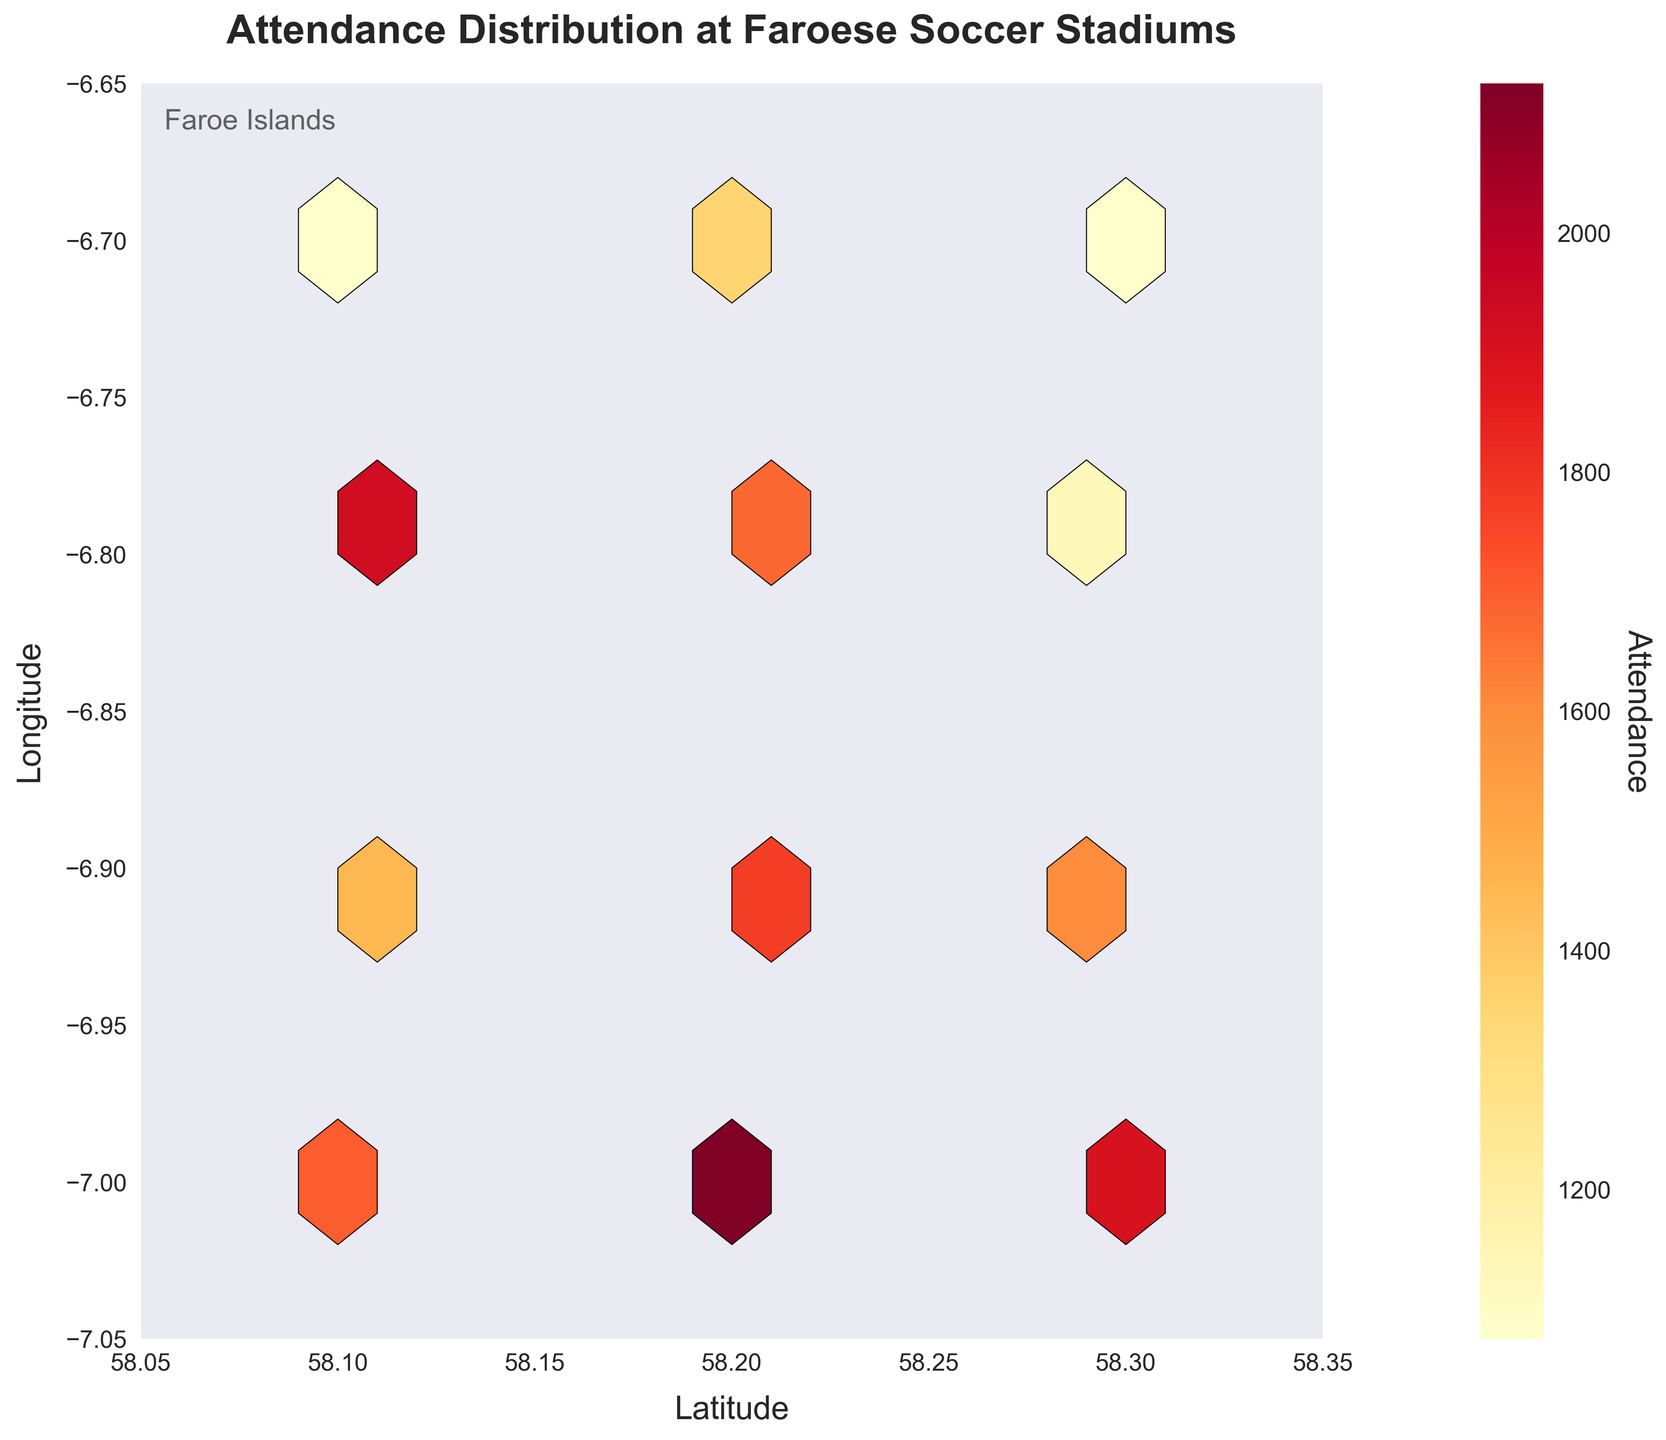What's the title of the plot? The title is usually prominently displayed at the top of the plot. Checking the provided plot, the title is "Attendance Distribution at Faroese Soccer Stadiums".
Answer: Attendance Distribution at Faroese Soccer Stadiums What do the colors represent in the hexbin plot? In a hexbin plot, colors are used to represent the magnitude or density of the underlying values within the hexagons. In this plot, the color bar indicates that the colors from yellow to red represent increasing attendance.
Answer: Attendance levels What are the x and y-axis labels? Axes labels are usually found next to the axes. From the plot, the x-axis is labeled "Latitude" and the y-axis is labeled "Longitude".
Answer: Latitude; Longitude Which latitude and longitude range does this plot cover? The axes limits can usually be inferred by looking at the ticks on the edges of the plot. The latitude ranges from 58.05 to 58.35 and the longitude ranges from -7.05 to -6.65.
Answer: Latitude: 58.05 to 58.35; Longitude: -7.05 to -6.65 What area seems to have the highest concentration of attendance? Areas of highest density are usually depicted in the darkest or most intense colors. The highest concentration in this plot is around (58.2, -6.8) as it is the darkest region.
Answer: Around (58.2, -6.8) Do more northern or southern stadiums appear to have higher attendances on average? By comparing the overall color intensity between the northern and southern regions, you can determine which has higher attendances. More northern stadiums (higher latitudes) appear to have a deeper color, indicating higher attendances.
Answer: Northern stadiums Is there a location with extremely low attendance? Areas with lighter colors (yellow in this case) indicate lower attendance. From the plot, the coordinates around (58.3, -6.7) appear to have relatively lower attendance.
Answer: Around (58.3, -6.7) How does attendance change from east to west? By examining the color gradient from left (west) to right (east), you can infer the trend. The attendance appears to be more variable with some clusters of high and low attendance, but tends to be higher in the middle of the plot.
Answer: Variable, clustering higher in the middle Which specific point marks the highest attendance on the map? The highest attendance can be identified by finding the deepest color on the plot. The coordinates (58.2, -7.0) show the darkest hexagon which represents the highest attendance value.
Answer: (58.2, -7.0) What information does the color bar provide? The color bar typically translates the colors on the plot to their corresponding values. In this figure, it shows that attendance ranges from lower values (yellow) to higher values (red).
Answer: Attendance range 